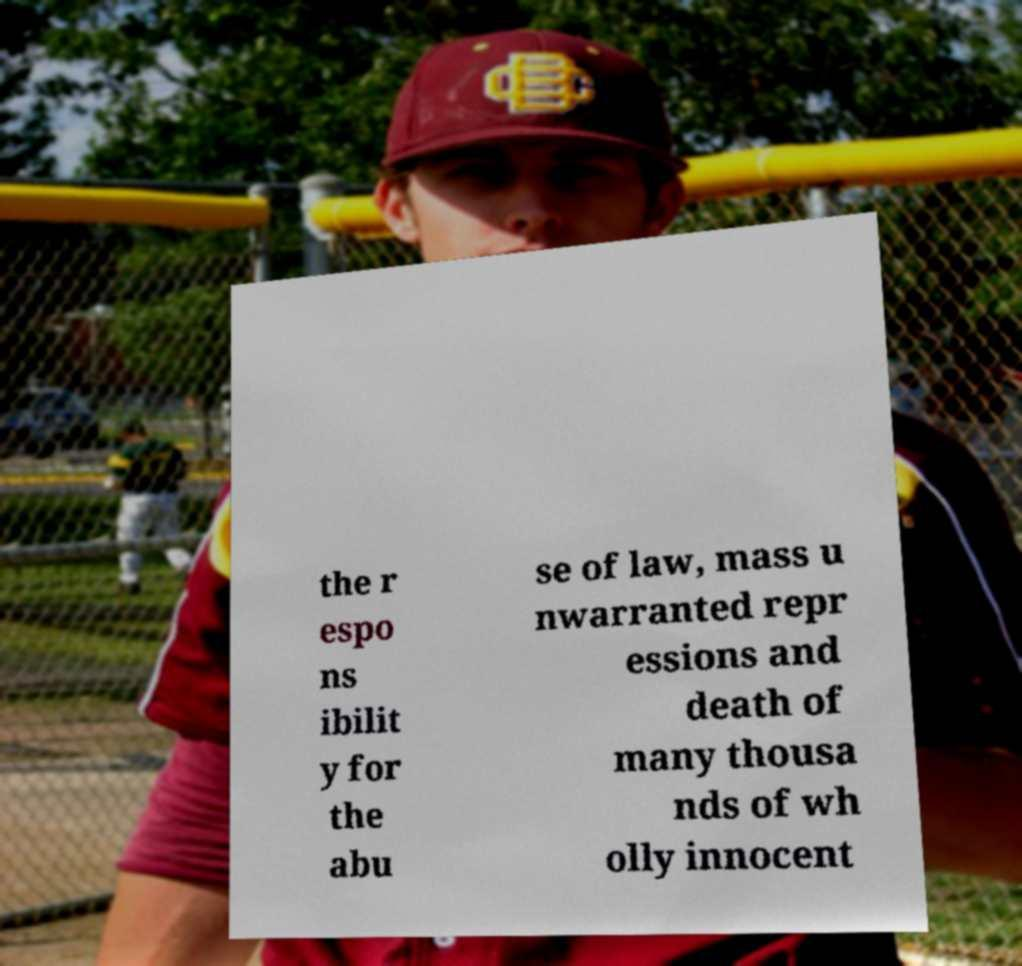Please read and relay the text visible in this image. What does it say? the r espo ns ibilit y for the abu se of law, mass u nwarranted repr essions and death of many thousa nds of wh olly innocent 